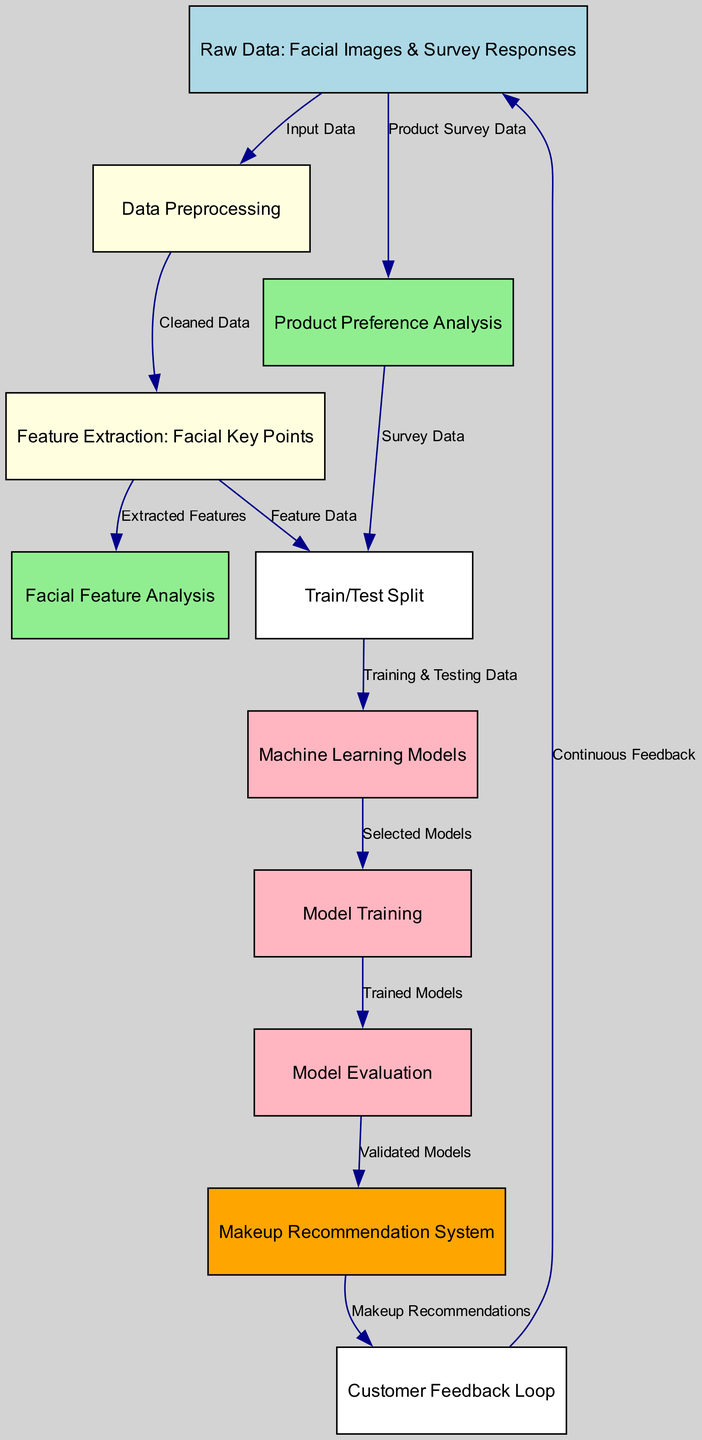What is the starting point for the diagram? The diagram begins with the "Raw Data: Facial Images & Survey Responses" node, which serves as the foundational input to the entire process.
Answer: Raw Data: Facial Images & Survey Responses How many nodes are present in the diagram? By counting each unique node listed in the data, we find a total of eleven nodes included in the diagram's structure.
Answer: Eleven What comes after Data Preprocessing? After "Data Preprocessing," the next step in the flow is "Feature Extraction: Facial Key Points," indicating the process of extracting relevant features from the cleaned data.
Answer: Feature Extraction: Facial Key Points Which node is connected to both Product Preference Analysis and Train/Test Split? The node "Train/Test Split" receives input from "Product Preference Analysis" as well as "Feature Extraction," linking survey data and extracted facial features.
Answer: Train/Test Split What is the purpose of the Customer Feedback Loop? The "Customer Feedback Loop" collects continuous feedback about makeup recommendations, creating a system that can improve future predictions and recommendations based on user experiences.
Answer: Continuous Feedback Explain the flow from Model Evaluation to Recommendation System. After the "Model Evaluation," which assesses the validity of the models, the valid models transition to the "Makeup Recommendation System." This shows that only those models, which perform well, are used to generate actual makeup recommendations for users.
Answer: Validated Models How many edges lead into the Facial Feature Analysis node? "Facial Feature Analysis" receives input from "Feature Extraction," establishing a single edge leading into this specific analysis step.
Answer: One What does Customer Feedback connect back to? The "Customer Feedback Loop" ultimately connects back to the "Raw Data: Facial Images & Survey Responses" node, reinforcing the importance of that data in refining the overall process based on user feedback.
Answer: Raw Data: Facial Images & Survey Responses Which type of models is selected after the Train/Test Split? After the "Train/Test Split," a node labelled "Machine Learning Models" selects and utilizes machine learning models based on the training and testing data prepared from previous steps.
Answer: Machine Learning Models 